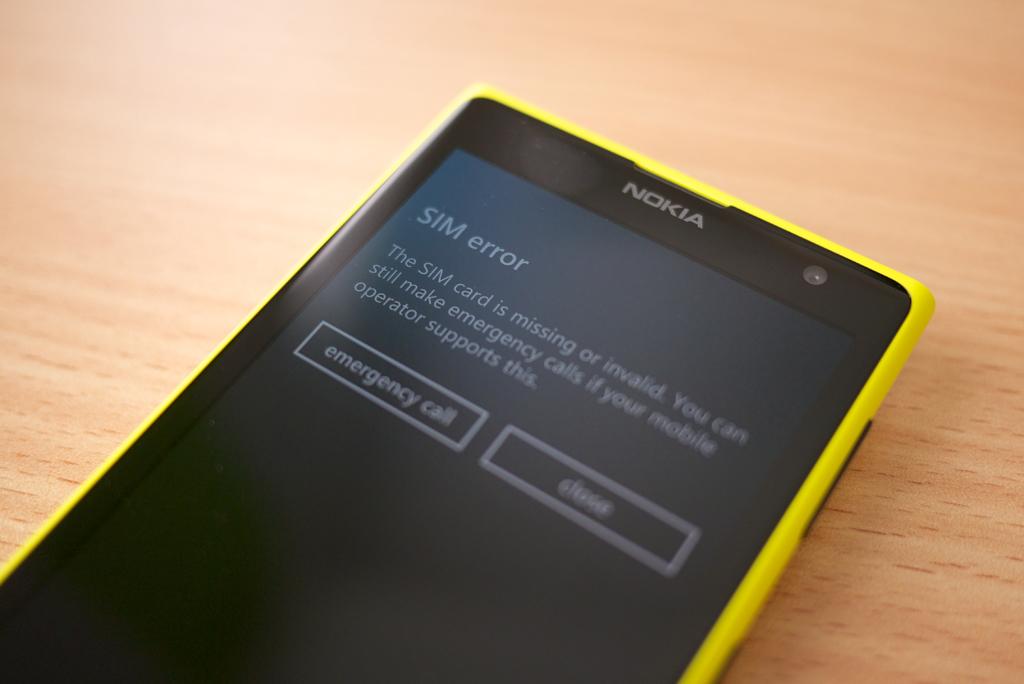What kind of error is displayed?
Provide a short and direct response. Sim. What kind of call is available?
Offer a very short reply. Emergency. 